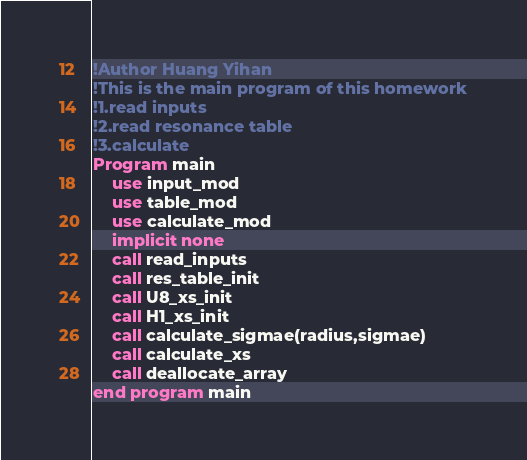Convert code to text. <code><loc_0><loc_0><loc_500><loc_500><_FORTRAN_>!Author Huang Yihan
!This is the main program of this homework
!1.read inputs
!2.read resonance table
!3.calculate
Program main
    use input_mod
    use table_mod
    use calculate_mod
    implicit none
    call read_inputs
    call res_table_init
    call U8_xs_init
    call H1_xs_init
    call calculate_sigmae(radius,sigmae)
    call calculate_xs
    call deallocate_array
end program main</code> 